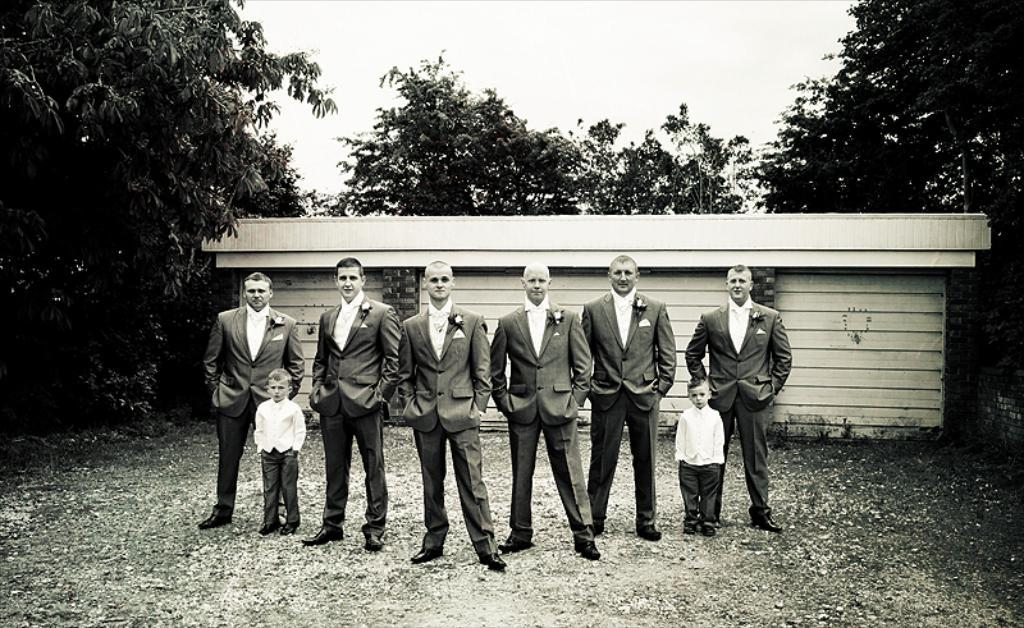How many people are in the image? There is a group of men and two boys in the image, making a total of at least five people. What is the location of the people in the image? The people are standing on the ground. What can be seen in the background of the image? There is a shed, trees, and the sky visible in the background of the image. What type of pest is visible on the boys' apparel in the image? There is no pest visible on the boys' apparel in the image. 